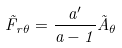<formula> <loc_0><loc_0><loc_500><loc_500>\vec { F } _ { r \theta } = \frac { a ^ { \prime } } { a - 1 } \vec { A } _ { \theta }</formula> 